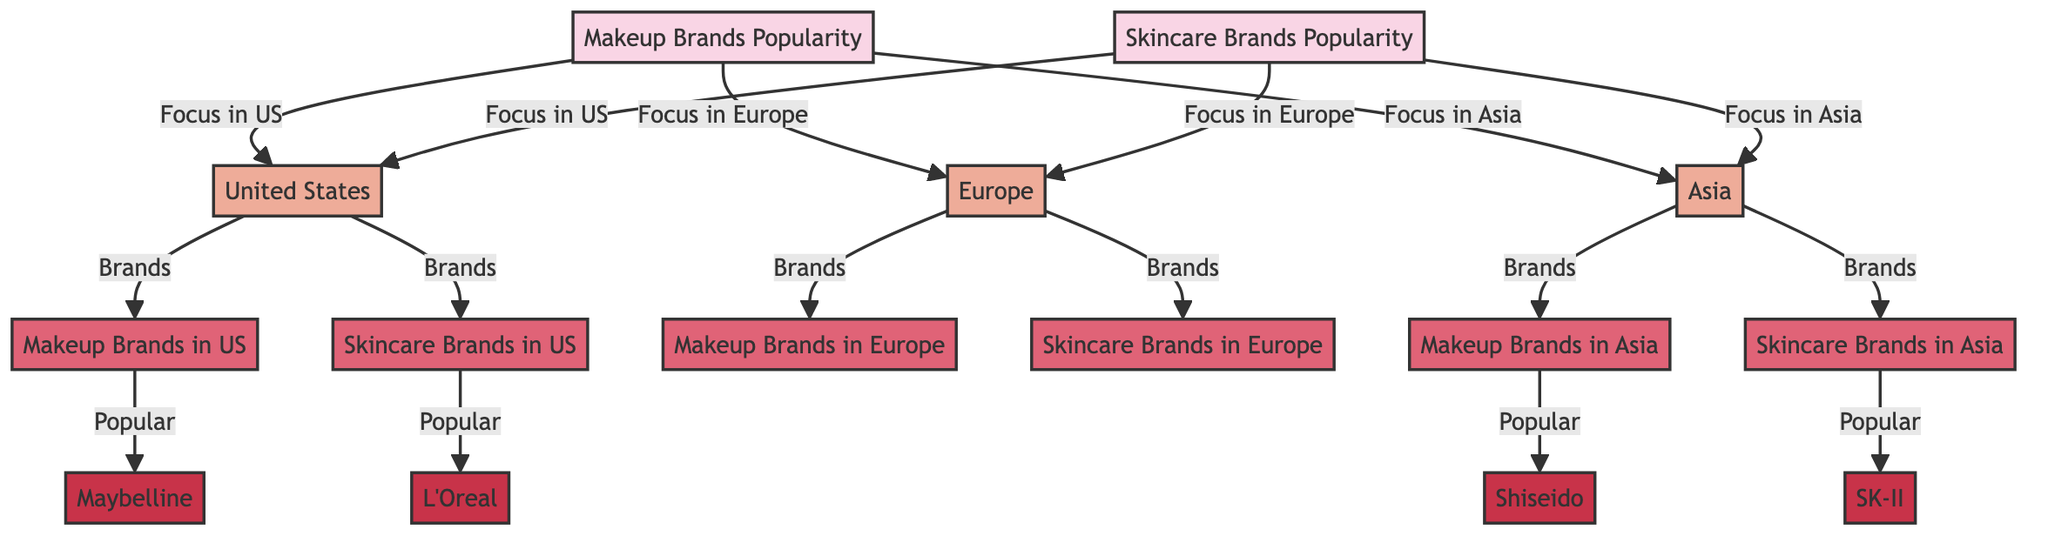What regions are depicted in the diagram? The diagram consists of three regions: the United States, Europe, and Asia. This can be identified by the branching from the main themes of makeup and skincare brands popularity.
Answer: United States, Europe, Asia How many popular makeup brands are listed for the US? The diagram indicates one popular makeup brand for the US, which is Maybelline, as shown in the connection from the region to the specific brand.
Answer: 1 Which brand is associated with skincare in the US? The diagram directly links the skincare brands in the US to L'Oreal, which is the only brand listed under that region for skincare.
Answer: L'Oreal What is the most popular makeup brand in Asia according to the diagram? In the Asia region section of the diagram, Shiseido is identified as the popular makeup brand, making it the focus for that region under makeup.
Answer: Shiseido Explain the connection between skincare and Europe according to the diagram. The diagram describes skincare brands popularity spread across regions, with Europe specifically connected to its own skincare brand category. However, it does not specify a particular brand, indicating only the categorization. This implies that there are skincare brands present, but none are detailed in the diagram for Europe.
Answer: (No specific brand listed) How many nodes are there for skincare brands? In total, the diagram contains three nodes that represent skincare brands: L'Oreal for the US, one unspecified for Europe, and SK-II for Asia. Therefore, counting all these nodes gives us the total number.
Answer: 3 Which is the popular skincare brand in Asia according to the diagram? The diagram indicates that the popular skincare brand in Asia is SK-II, as this brand is specifically linked under the Asia section of skincare.
Answer: SK-II What links the regions to their respective brands in the diagram? The connections between the regions and their respective brands are established through the categories of makeup and skincare popularity. Each region has arrows directing to the brands, creating a clear organizational structure in the diagram. This indicates direct relationships rather than separate randomities.
Answer: Arrows 